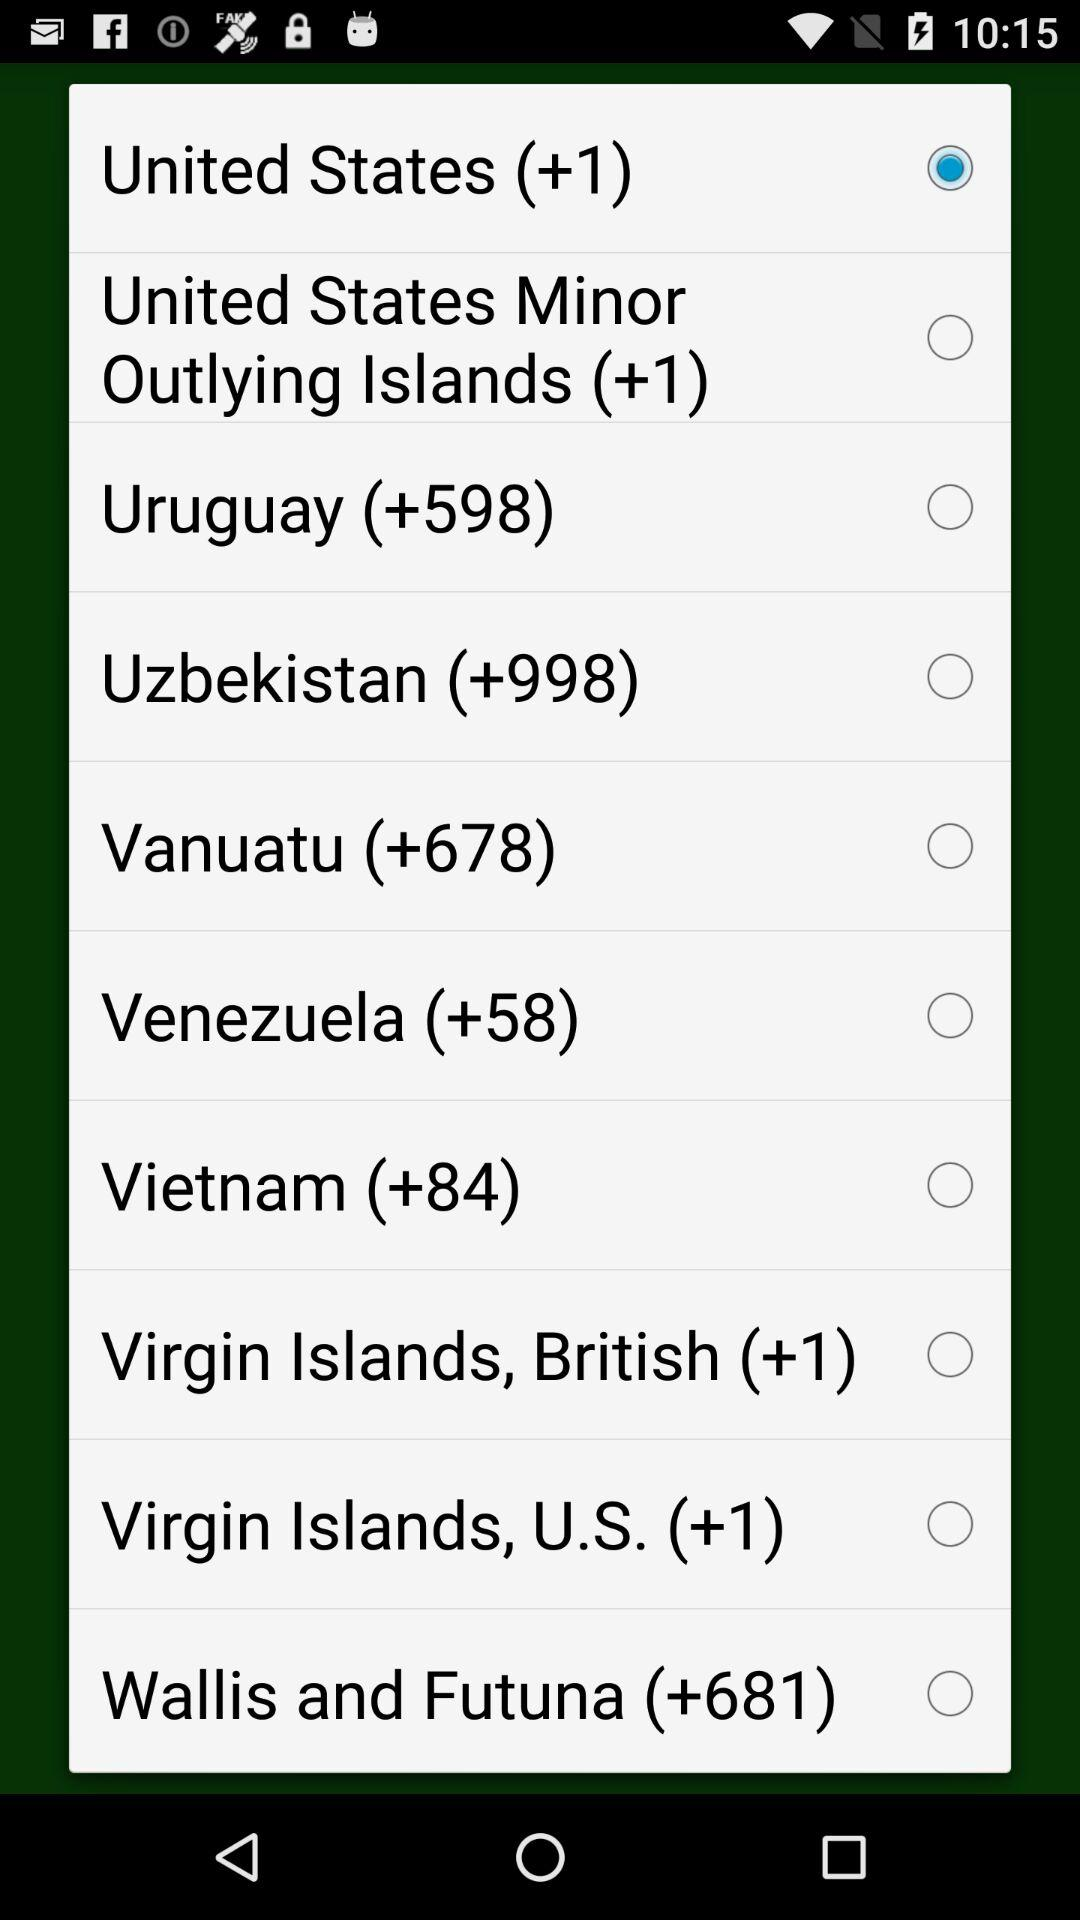What is the code of Venezuela? The code of Venezuela is +58. 